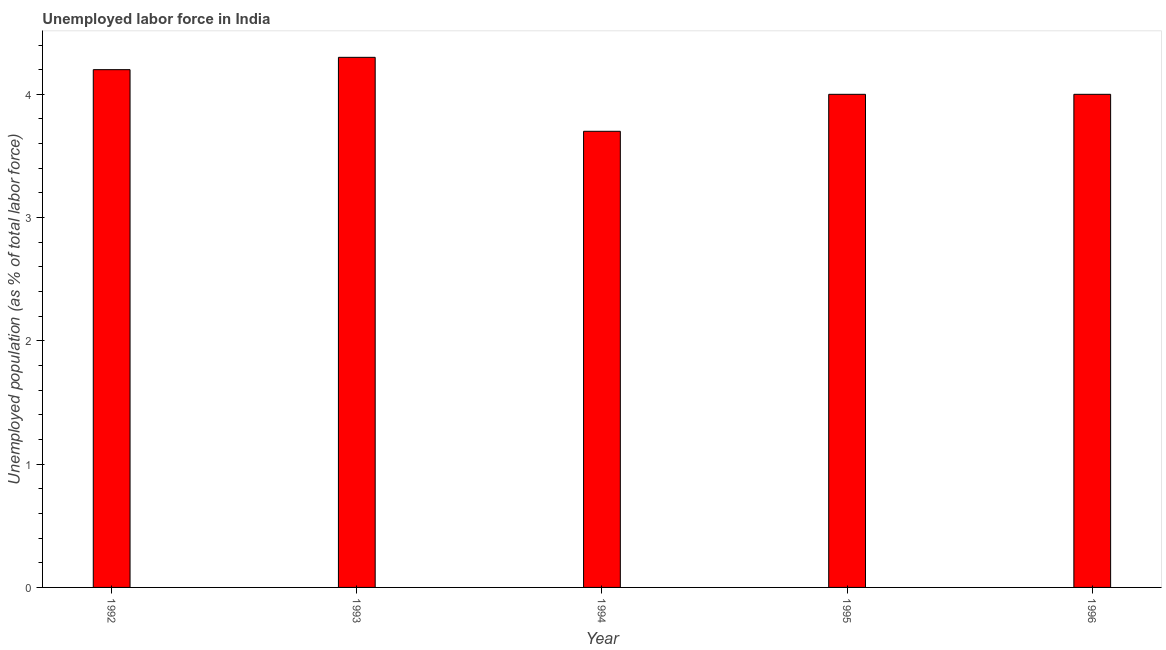Does the graph contain grids?
Your response must be concise. No. What is the title of the graph?
Give a very brief answer. Unemployed labor force in India. What is the label or title of the Y-axis?
Make the answer very short. Unemployed population (as % of total labor force). What is the total unemployed population in 1994?
Your answer should be compact. 3.7. Across all years, what is the maximum total unemployed population?
Your answer should be very brief. 4.3. Across all years, what is the minimum total unemployed population?
Offer a terse response. 3.7. In which year was the total unemployed population maximum?
Provide a succinct answer. 1993. In which year was the total unemployed population minimum?
Ensure brevity in your answer.  1994. What is the sum of the total unemployed population?
Your answer should be very brief. 20.2. What is the average total unemployed population per year?
Make the answer very short. 4.04. What is the median total unemployed population?
Give a very brief answer. 4. In how many years, is the total unemployed population greater than 3 %?
Make the answer very short. 5. Do a majority of the years between 1992 and 1995 (inclusive) have total unemployed population greater than 1.4 %?
Your answer should be compact. Yes. What is the ratio of the total unemployed population in 1993 to that in 1994?
Your answer should be compact. 1.16. Is the total unemployed population in 1992 less than that in 1994?
Offer a very short reply. No. Is the difference between the total unemployed population in 1995 and 1996 greater than the difference between any two years?
Your answer should be compact. No. What is the difference between the highest and the second highest total unemployed population?
Offer a terse response. 0.1. Is the sum of the total unemployed population in 1992 and 1996 greater than the maximum total unemployed population across all years?
Provide a succinct answer. Yes. How many bars are there?
Your response must be concise. 5. Are the values on the major ticks of Y-axis written in scientific E-notation?
Give a very brief answer. No. What is the Unemployed population (as % of total labor force) of 1992?
Offer a very short reply. 4.2. What is the Unemployed population (as % of total labor force) of 1993?
Give a very brief answer. 4.3. What is the Unemployed population (as % of total labor force) in 1994?
Your answer should be very brief. 3.7. What is the Unemployed population (as % of total labor force) in 1995?
Offer a very short reply. 4. What is the difference between the Unemployed population (as % of total labor force) in 1992 and 1993?
Offer a terse response. -0.1. What is the difference between the Unemployed population (as % of total labor force) in 1992 and 1996?
Provide a succinct answer. 0.2. What is the difference between the Unemployed population (as % of total labor force) in 1993 and 1994?
Your answer should be compact. 0.6. What is the difference between the Unemployed population (as % of total labor force) in 1993 and 1995?
Your response must be concise. 0.3. What is the difference between the Unemployed population (as % of total labor force) in 1993 and 1996?
Ensure brevity in your answer.  0.3. What is the difference between the Unemployed population (as % of total labor force) in 1994 and 1996?
Offer a very short reply. -0.3. What is the ratio of the Unemployed population (as % of total labor force) in 1992 to that in 1994?
Ensure brevity in your answer.  1.14. What is the ratio of the Unemployed population (as % of total labor force) in 1992 to that in 1995?
Your answer should be very brief. 1.05. What is the ratio of the Unemployed population (as % of total labor force) in 1992 to that in 1996?
Ensure brevity in your answer.  1.05. What is the ratio of the Unemployed population (as % of total labor force) in 1993 to that in 1994?
Your response must be concise. 1.16. What is the ratio of the Unemployed population (as % of total labor force) in 1993 to that in 1995?
Your response must be concise. 1.07. What is the ratio of the Unemployed population (as % of total labor force) in 1993 to that in 1996?
Provide a succinct answer. 1.07. What is the ratio of the Unemployed population (as % of total labor force) in 1994 to that in 1995?
Offer a very short reply. 0.93. What is the ratio of the Unemployed population (as % of total labor force) in 1994 to that in 1996?
Your answer should be very brief. 0.93. 